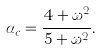<formula> <loc_0><loc_0><loc_500><loc_500>\alpha _ { c } = \frac { 4 + \omega ^ { 2 } } { 5 + \omega ^ { 2 } } .</formula> 